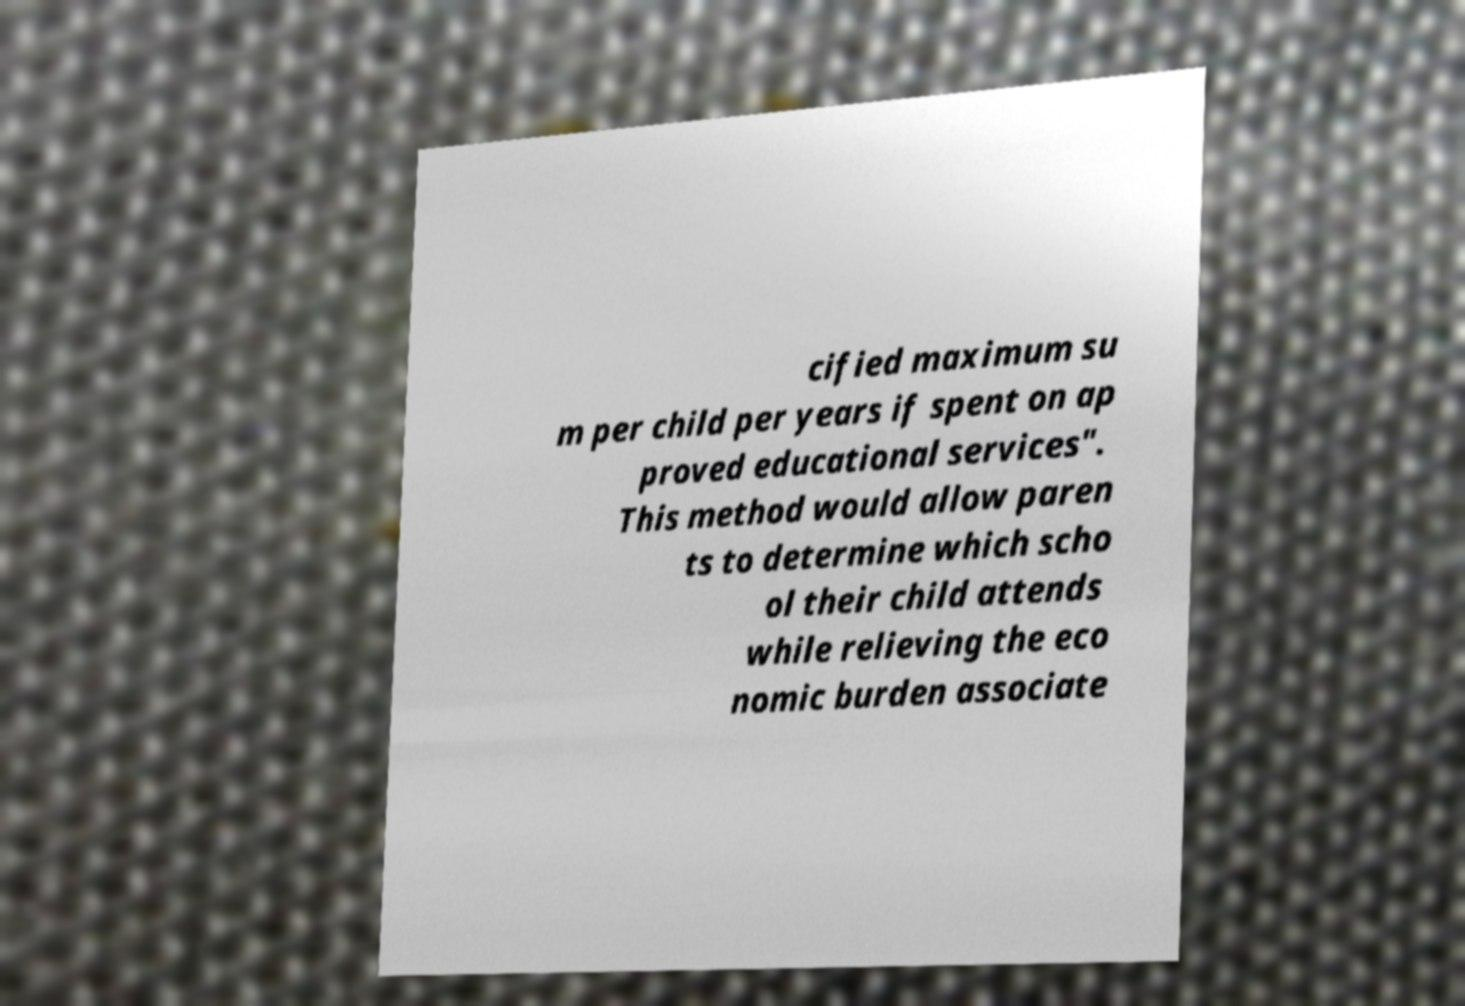Please read and relay the text visible in this image. What does it say? cified maximum su m per child per years if spent on ap proved educational services". This method would allow paren ts to determine which scho ol their child attends while relieving the eco nomic burden associate 